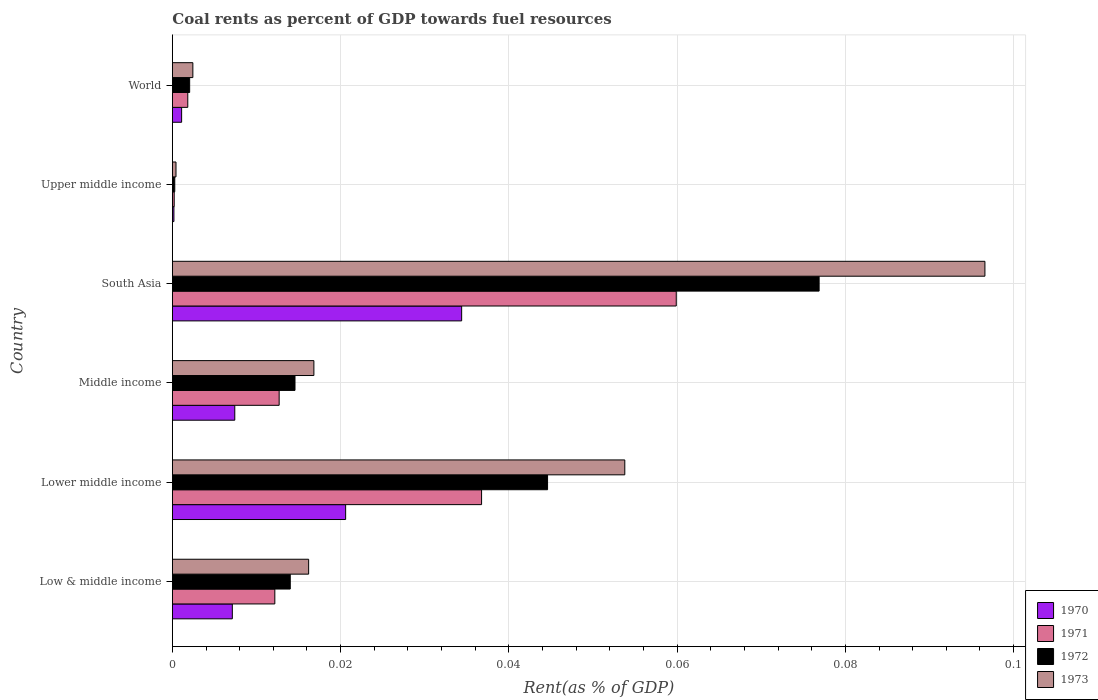What is the label of the 1st group of bars from the top?
Keep it short and to the point. World. What is the coal rent in 1973 in Lower middle income?
Ensure brevity in your answer.  0.05. Across all countries, what is the maximum coal rent in 1971?
Your response must be concise. 0.06. Across all countries, what is the minimum coal rent in 1972?
Provide a succinct answer. 0. In which country was the coal rent in 1972 minimum?
Make the answer very short. Upper middle income. What is the total coal rent in 1971 in the graph?
Provide a short and direct response. 0.12. What is the difference between the coal rent in 1971 in Lower middle income and that in World?
Provide a succinct answer. 0.03. What is the difference between the coal rent in 1973 in Lower middle income and the coal rent in 1970 in Upper middle income?
Offer a very short reply. 0.05. What is the average coal rent in 1970 per country?
Provide a succinct answer. 0.01. What is the difference between the coal rent in 1970 and coal rent in 1973 in South Asia?
Keep it short and to the point. -0.06. What is the ratio of the coal rent in 1971 in Middle income to that in South Asia?
Your answer should be compact. 0.21. Is the coal rent in 1971 in Low & middle income less than that in Middle income?
Offer a terse response. Yes. Is the difference between the coal rent in 1970 in Lower middle income and South Asia greater than the difference between the coal rent in 1973 in Lower middle income and South Asia?
Your answer should be very brief. Yes. What is the difference between the highest and the second highest coal rent in 1973?
Your answer should be very brief. 0.04. What is the difference between the highest and the lowest coal rent in 1972?
Provide a succinct answer. 0.08. Is the sum of the coal rent in 1970 in Lower middle income and Upper middle income greater than the maximum coal rent in 1973 across all countries?
Offer a very short reply. No. What does the 2nd bar from the top in Upper middle income represents?
Offer a very short reply. 1972. How many countries are there in the graph?
Give a very brief answer. 6. What is the difference between two consecutive major ticks on the X-axis?
Offer a very short reply. 0.02. Does the graph contain any zero values?
Offer a terse response. No. Does the graph contain grids?
Provide a succinct answer. Yes. How are the legend labels stacked?
Provide a succinct answer. Vertical. What is the title of the graph?
Provide a short and direct response. Coal rents as percent of GDP towards fuel resources. What is the label or title of the X-axis?
Your response must be concise. Rent(as % of GDP). What is the label or title of the Y-axis?
Ensure brevity in your answer.  Country. What is the Rent(as % of GDP) of 1970 in Low & middle income?
Offer a very short reply. 0.01. What is the Rent(as % of GDP) in 1971 in Low & middle income?
Give a very brief answer. 0.01. What is the Rent(as % of GDP) of 1972 in Low & middle income?
Your answer should be compact. 0.01. What is the Rent(as % of GDP) of 1973 in Low & middle income?
Your answer should be compact. 0.02. What is the Rent(as % of GDP) of 1970 in Lower middle income?
Offer a very short reply. 0.02. What is the Rent(as % of GDP) of 1971 in Lower middle income?
Keep it short and to the point. 0.04. What is the Rent(as % of GDP) of 1972 in Lower middle income?
Give a very brief answer. 0.04. What is the Rent(as % of GDP) of 1973 in Lower middle income?
Your answer should be very brief. 0.05. What is the Rent(as % of GDP) in 1970 in Middle income?
Your answer should be very brief. 0.01. What is the Rent(as % of GDP) in 1971 in Middle income?
Your response must be concise. 0.01. What is the Rent(as % of GDP) of 1972 in Middle income?
Offer a very short reply. 0.01. What is the Rent(as % of GDP) in 1973 in Middle income?
Offer a terse response. 0.02. What is the Rent(as % of GDP) in 1970 in South Asia?
Keep it short and to the point. 0.03. What is the Rent(as % of GDP) of 1971 in South Asia?
Make the answer very short. 0.06. What is the Rent(as % of GDP) of 1972 in South Asia?
Provide a short and direct response. 0.08. What is the Rent(as % of GDP) of 1973 in South Asia?
Keep it short and to the point. 0.1. What is the Rent(as % of GDP) of 1970 in Upper middle income?
Ensure brevity in your answer.  0. What is the Rent(as % of GDP) of 1971 in Upper middle income?
Give a very brief answer. 0. What is the Rent(as % of GDP) in 1972 in Upper middle income?
Your answer should be very brief. 0. What is the Rent(as % of GDP) of 1973 in Upper middle income?
Make the answer very short. 0. What is the Rent(as % of GDP) in 1970 in World?
Offer a very short reply. 0. What is the Rent(as % of GDP) in 1971 in World?
Your answer should be compact. 0. What is the Rent(as % of GDP) in 1972 in World?
Your response must be concise. 0. What is the Rent(as % of GDP) of 1973 in World?
Give a very brief answer. 0. Across all countries, what is the maximum Rent(as % of GDP) in 1970?
Ensure brevity in your answer.  0.03. Across all countries, what is the maximum Rent(as % of GDP) in 1971?
Ensure brevity in your answer.  0.06. Across all countries, what is the maximum Rent(as % of GDP) of 1972?
Your answer should be compact. 0.08. Across all countries, what is the maximum Rent(as % of GDP) in 1973?
Keep it short and to the point. 0.1. Across all countries, what is the minimum Rent(as % of GDP) in 1970?
Offer a terse response. 0. Across all countries, what is the minimum Rent(as % of GDP) in 1971?
Your answer should be very brief. 0. Across all countries, what is the minimum Rent(as % of GDP) in 1972?
Offer a terse response. 0. Across all countries, what is the minimum Rent(as % of GDP) in 1973?
Offer a terse response. 0. What is the total Rent(as % of GDP) in 1970 in the graph?
Provide a short and direct response. 0.07. What is the total Rent(as % of GDP) in 1971 in the graph?
Offer a very short reply. 0.12. What is the total Rent(as % of GDP) in 1972 in the graph?
Offer a very short reply. 0.15. What is the total Rent(as % of GDP) in 1973 in the graph?
Make the answer very short. 0.19. What is the difference between the Rent(as % of GDP) of 1970 in Low & middle income and that in Lower middle income?
Offer a very short reply. -0.01. What is the difference between the Rent(as % of GDP) of 1971 in Low & middle income and that in Lower middle income?
Ensure brevity in your answer.  -0.02. What is the difference between the Rent(as % of GDP) of 1972 in Low & middle income and that in Lower middle income?
Offer a terse response. -0.03. What is the difference between the Rent(as % of GDP) in 1973 in Low & middle income and that in Lower middle income?
Your answer should be compact. -0.04. What is the difference between the Rent(as % of GDP) of 1970 in Low & middle income and that in Middle income?
Provide a succinct answer. -0. What is the difference between the Rent(as % of GDP) in 1971 in Low & middle income and that in Middle income?
Provide a succinct answer. -0. What is the difference between the Rent(as % of GDP) in 1972 in Low & middle income and that in Middle income?
Offer a terse response. -0. What is the difference between the Rent(as % of GDP) in 1973 in Low & middle income and that in Middle income?
Make the answer very short. -0. What is the difference between the Rent(as % of GDP) of 1970 in Low & middle income and that in South Asia?
Your answer should be compact. -0.03. What is the difference between the Rent(as % of GDP) of 1971 in Low & middle income and that in South Asia?
Give a very brief answer. -0.05. What is the difference between the Rent(as % of GDP) of 1972 in Low & middle income and that in South Asia?
Provide a succinct answer. -0.06. What is the difference between the Rent(as % of GDP) in 1973 in Low & middle income and that in South Asia?
Offer a very short reply. -0.08. What is the difference between the Rent(as % of GDP) of 1970 in Low & middle income and that in Upper middle income?
Your answer should be compact. 0.01. What is the difference between the Rent(as % of GDP) in 1971 in Low & middle income and that in Upper middle income?
Make the answer very short. 0.01. What is the difference between the Rent(as % of GDP) in 1972 in Low & middle income and that in Upper middle income?
Your answer should be compact. 0.01. What is the difference between the Rent(as % of GDP) in 1973 in Low & middle income and that in Upper middle income?
Give a very brief answer. 0.02. What is the difference between the Rent(as % of GDP) in 1970 in Low & middle income and that in World?
Offer a very short reply. 0.01. What is the difference between the Rent(as % of GDP) of 1971 in Low & middle income and that in World?
Ensure brevity in your answer.  0.01. What is the difference between the Rent(as % of GDP) of 1972 in Low & middle income and that in World?
Your answer should be very brief. 0.01. What is the difference between the Rent(as % of GDP) of 1973 in Low & middle income and that in World?
Keep it short and to the point. 0.01. What is the difference between the Rent(as % of GDP) in 1970 in Lower middle income and that in Middle income?
Keep it short and to the point. 0.01. What is the difference between the Rent(as % of GDP) in 1971 in Lower middle income and that in Middle income?
Your answer should be very brief. 0.02. What is the difference between the Rent(as % of GDP) of 1973 in Lower middle income and that in Middle income?
Offer a very short reply. 0.04. What is the difference between the Rent(as % of GDP) in 1970 in Lower middle income and that in South Asia?
Ensure brevity in your answer.  -0.01. What is the difference between the Rent(as % of GDP) in 1971 in Lower middle income and that in South Asia?
Offer a very short reply. -0.02. What is the difference between the Rent(as % of GDP) of 1972 in Lower middle income and that in South Asia?
Offer a very short reply. -0.03. What is the difference between the Rent(as % of GDP) in 1973 in Lower middle income and that in South Asia?
Offer a very short reply. -0.04. What is the difference between the Rent(as % of GDP) of 1970 in Lower middle income and that in Upper middle income?
Keep it short and to the point. 0.02. What is the difference between the Rent(as % of GDP) of 1971 in Lower middle income and that in Upper middle income?
Ensure brevity in your answer.  0.04. What is the difference between the Rent(as % of GDP) of 1972 in Lower middle income and that in Upper middle income?
Your answer should be compact. 0.04. What is the difference between the Rent(as % of GDP) in 1973 in Lower middle income and that in Upper middle income?
Offer a terse response. 0.05. What is the difference between the Rent(as % of GDP) of 1970 in Lower middle income and that in World?
Your response must be concise. 0.02. What is the difference between the Rent(as % of GDP) of 1971 in Lower middle income and that in World?
Offer a terse response. 0.03. What is the difference between the Rent(as % of GDP) of 1972 in Lower middle income and that in World?
Offer a very short reply. 0.04. What is the difference between the Rent(as % of GDP) in 1973 in Lower middle income and that in World?
Ensure brevity in your answer.  0.05. What is the difference between the Rent(as % of GDP) of 1970 in Middle income and that in South Asia?
Your answer should be compact. -0.03. What is the difference between the Rent(as % of GDP) in 1971 in Middle income and that in South Asia?
Provide a succinct answer. -0.05. What is the difference between the Rent(as % of GDP) of 1972 in Middle income and that in South Asia?
Your response must be concise. -0.06. What is the difference between the Rent(as % of GDP) in 1973 in Middle income and that in South Asia?
Your response must be concise. -0.08. What is the difference between the Rent(as % of GDP) of 1970 in Middle income and that in Upper middle income?
Your answer should be very brief. 0.01. What is the difference between the Rent(as % of GDP) in 1971 in Middle income and that in Upper middle income?
Give a very brief answer. 0.01. What is the difference between the Rent(as % of GDP) in 1972 in Middle income and that in Upper middle income?
Offer a very short reply. 0.01. What is the difference between the Rent(as % of GDP) in 1973 in Middle income and that in Upper middle income?
Your response must be concise. 0.02. What is the difference between the Rent(as % of GDP) in 1970 in Middle income and that in World?
Offer a terse response. 0.01. What is the difference between the Rent(as % of GDP) of 1971 in Middle income and that in World?
Provide a succinct answer. 0.01. What is the difference between the Rent(as % of GDP) of 1972 in Middle income and that in World?
Ensure brevity in your answer.  0.01. What is the difference between the Rent(as % of GDP) in 1973 in Middle income and that in World?
Your answer should be very brief. 0.01. What is the difference between the Rent(as % of GDP) of 1970 in South Asia and that in Upper middle income?
Keep it short and to the point. 0.03. What is the difference between the Rent(as % of GDP) in 1971 in South Asia and that in Upper middle income?
Your response must be concise. 0.06. What is the difference between the Rent(as % of GDP) of 1972 in South Asia and that in Upper middle income?
Provide a succinct answer. 0.08. What is the difference between the Rent(as % of GDP) of 1973 in South Asia and that in Upper middle income?
Offer a very short reply. 0.1. What is the difference between the Rent(as % of GDP) in 1970 in South Asia and that in World?
Keep it short and to the point. 0.03. What is the difference between the Rent(as % of GDP) of 1971 in South Asia and that in World?
Your answer should be very brief. 0.06. What is the difference between the Rent(as % of GDP) of 1972 in South Asia and that in World?
Your answer should be very brief. 0.07. What is the difference between the Rent(as % of GDP) of 1973 in South Asia and that in World?
Provide a short and direct response. 0.09. What is the difference between the Rent(as % of GDP) in 1970 in Upper middle income and that in World?
Keep it short and to the point. -0. What is the difference between the Rent(as % of GDP) of 1971 in Upper middle income and that in World?
Your answer should be compact. -0. What is the difference between the Rent(as % of GDP) of 1972 in Upper middle income and that in World?
Provide a short and direct response. -0. What is the difference between the Rent(as % of GDP) in 1973 in Upper middle income and that in World?
Your answer should be very brief. -0. What is the difference between the Rent(as % of GDP) in 1970 in Low & middle income and the Rent(as % of GDP) in 1971 in Lower middle income?
Your answer should be very brief. -0.03. What is the difference between the Rent(as % of GDP) of 1970 in Low & middle income and the Rent(as % of GDP) of 1972 in Lower middle income?
Provide a short and direct response. -0.04. What is the difference between the Rent(as % of GDP) in 1970 in Low & middle income and the Rent(as % of GDP) in 1973 in Lower middle income?
Make the answer very short. -0.05. What is the difference between the Rent(as % of GDP) of 1971 in Low & middle income and the Rent(as % of GDP) of 1972 in Lower middle income?
Your answer should be very brief. -0.03. What is the difference between the Rent(as % of GDP) in 1971 in Low & middle income and the Rent(as % of GDP) in 1973 in Lower middle income?
Your answer should be very brief. -0.04. What is the difference between the Rent(as % of GDP) of 1972 in Low & middle income and the Rent(as % of GDP) of 1973 in Lower middle income?
Give a very brief answer. -0.04. What is the difference between the Rent(as % of GDP) of 1970 in Low & middle income and the Rent(as % of GDP) of 1971 in Middle income?
Provide a short and direct response. -0.01. What is the difference between the Rent(as % of GDP) of 1970 in Low & middle income and the Rent(as % of GDP) of 1972 in Middle income?
Your response must be concise. -0.01. What is the difference between the Rent(as % of GDP) of 1970 in Low & middle income and the Rent(as % of GDP) of 1973 in Middle income?
Give a very brief answer. -0.01. What is the difference between the Rent(as % of GDP) of 1971 in Low & middle income and the Rent(as % of GDP) of 1972 in Middle income?
Your answer should be very brief. -0. What is the difference between the Rent(as % of GDP) of 1971 in Low & middle income and the Rent(as % of GDP) of 1973 in Middle income?
Your response must be concise. -0. What is the difference between the Rent(as % of GDP) of 1972 in Low & middle income and the Rent(as % of GDP) of 1973 in Middle income?
Give a very brief answer. -0. What is the difference between the Rent(as % of GDP) in 1970 in Low & middle income and the Rent(as % of GDP) in 1971 in South Asia?
Give a very brief answer. -0.05. What is the difference between the Rent(as % of GDP) of 1970 in Low & middle income and the Rent(as % of GDP) of 1972 in South Asia?
Give a very brief answer. -0.07. What is the difference between the Rent(as % of GDP) in 1970 in Low & middle income and the Rent(as % of GDP) in 1973 in South Asia?
Your response must be concise. -0.09. What is the difference between the Rent(as % of GDP) of 1971 in Low & middle income and the Rent(as % of GDP) of 1972 in South Asia?
Your answer should be very brief. -0.06. What is the difference between the Rent(as % of GDP) in 1971 in Low & middle income and the Rent(as % of GDP) in 1973 in South Asia?
Your answer should be very brief. -0.08. What is the difference between the Rent(as % of GDP) of 1972 in Low & middle income and the Rent(as % of GDP) of 1973 in South Asia?
Make the answer very short. -0.08. What is the difference between the Rent(as % of GDP) of 1970 in Low & middle income and the Rent(as % of GDP) of 1971 in Upper middle income?
Offer a very short reply. 0.01. What is the difference between the Rent(as % of GDP) in 1970 in Low & middle income and the Rent(as % of GDP) in 1972 in Upper middle income?
Provide a short and direct response. 0.01. What is the difference between the Rent(as % of GDP) in 1970 in Low & middle income and the Rent(as % of GDP) in 1973 in Upper middle income?
Your answer should be compact. 0.01. What is the difference between the Rent(as % of GDP) in 1971 in Low & middle income and the Rent(as % of GDP) in 1972 in Upper middle income?
Make the answer very short. 0.01. What is the difference between the Rent(as % of GDP) in 1971 in Low & middle income and the Rent(as % of GDP) in 1973 in Upper middle income?
Provide a succinct answer. 0.01. What is the difference between the Rent(as % of GDP) in 1972 in Low & middle income and the Rent(as % of GDP) in 1973 in Upper middle income?
Your answer should be very brief. 0.01. What is the difference between the Rent(as % of GDP) in 1970 in Low & middle income and the Rent(as % of GDP) in 1971 in World?
Provide a succinct answer. 0.01. What is the difference between the Rent(as % of GDP) of 1970 in Low & middle income and the Rent(as % of GDP) of 1972 in World?
Offer a terse response. 0.01. What is the difference between the Rent(as % of GDP) in 1970 in Low & middle income and the Rent(as % of GDP) in 1973 in World?
Your answer should be compact. 0. What is the difference between the Rent(as % of GDP) of 1971 in Low & middle income and the Rent(as % of GDP) of 1972 in World?
Provide a succinct answer. 0.01. What is the difference between the Rent(as % of GDP) in 1971 in Low & middle income and the Rent(as % of GDP) in 1973 in World?
Your response must be concise. 0.01. What is the difference between the Rent(as % of GDP) of 1972 in Low & middle income and the Rent(as % of GDP) of 1973 in World?
Your answer should be compact. 0.01. What is the difference between the Rent(as % of GDP) in 1970 in Lower middle income and the Rent(as % of GDP) in 1971 in Middle income?
Offer a terse response. 0.01. What is the difference between the Rent(as % of GDP) in 1970 in Lower middle income and the Rent(as % of GDP) in 1972 in Middle income?
Provide a succinct answer. 0.01. What is the difference between the Rent(as % of GDP) in 1970 in Lower middle income and the Rent(as % of GDP) in 1973 in Middle income?
Give a very brief answer. 0. What is the difference between the Rent(as % of GDP) in 1971 in Lower middle income and the Rent(as % of GDP) in 1972 in Middle income?
Make the answer very short. 0.02. What is the difference between the Rent(as % of GDP) of 1971 in Lower middle income and the Rent(as % of GDP) of 1973 in Middle income?
Give a very brief answer. 0.02. What is the difference between the Rent(as % of GDP) of 1972 in Lower middle income and the Rent(as % of GDP) of 1973 in Middle income?
Provide a short and direct response. 0.03. What is the difference between the Rent(as % of GDP) of 1970 in Lower middle income and the Rent(as % of GDP) of 1971 in South Asia?
Your answer should be very brief. -0.04. What is the difference between the Rent(as % of GDP) of 1970 in Lower middle income and the Rent(as % of GDP) of 1972 in South Asia?
Ensure brevity in your answer.  -0.06. What is the difference between the Rent(as % of GDP) of 1970 in Lower middle income and the Rent(as % of GDP) of 1973 in South Asia?
Make the answer very short. -0.08. What is the difference between the Rent(as % of GDP) of 1971 in Lower middle income and the Rent(as % of GDP) of 1972 in South Asia?
Keep it short and to the point. -0.04. What is the difference between the Rent(as % of GDP) of 1971 in Lower middle income and the Rent(as % of GDP) of 1973 in South Asia?
Make the answer very short. -0.06. What is the difference between the Rent(as % of GDP) in 1972 in Lower middle income and the Rent(as % of GDP) in 1973 in South Asia?
Ensure brevity in your answer.  -0.05. What is the difference between the Rent(as % of GDP) in 1970 in Lower middle income and the Rent(as % of GDP) in 1971 in Upper middle income?
Offer a very short reply. 0.02. What is the difference between the Rent(as % of GDP) in 1970 in Lower middle income and the Rent(as % of GDP) in 1972 in Upper middle income?
Make the answer very short. 0.02. What is the difference between the Rent(as % of GDP) in 1970 in Lower middle income and the Rent(as % of GDP) in 1973 in Upper middle income?
Your answer should be compact. 0.02. What is the difference between the Rent(as % of GDP) in 1971 in Lower middle income and the Rent(as % of GDP) in 1972 in Upper middle income?
Your answer should be very brief. 0.04. What is the difference between the Rent(as % of GDP) of 1971 in Lower middle income and the Rent(as % of GDP) of 1973 in Upper middle income?
Keep it short and to the point. 0.04. What is the difference between the Rent(as % of GDP) in 1972 in Lower middle income and the Rent(as % of GDP) in 1973 in Upper middle income?
Make the answer very short. 0.04. What is the difference between the Rent(as % of GDP) of 1970 in Lower middle income and the Rent(as % of GDP) of 1971 in World?
Ensure brevity in your answer.  0.02. What is the difference between the Rent(as % of GDP) in 1970 in Lower middle income and the Rent(as % of GDP) in 1972 in World?
Give a very brief answer. 0.02. What is the difference between the Rent(as % of GDP) in 1970 in Lower middle income and the Rent(as % of GDP) in 1973 in World?
Make the answer very short. 0.02. What is the difference between the Rent(as % of GDP) of 1971 in Lower middle income and the Rent(as % of GDP) of 1972 in World?
Your response must be concise. 0.03. What is the difference between the Rent(as % of GDP) of 1971 in Lower middle income and the Rent(as % of GDP) of 1973 in World?
Your answer should be compact. 0.03. What is the difference between the Rent(as % of GDP) of 1972 in Lower middle income and the Rent(as % of GDP) of 1973 in World?
Your answer should be compact. 0.04. What is the difference between the Rent(as % of GDP) of 1970 in Middle income and the Rent(as % of GDP) of 1971 in South Asia?
Provide a short and direct response. -0.05. What is the difference between the Rent(as % of GDP) of 1970 in Middle income and the Rent(as % of GDP) of 1972 in South Asia?
Your answer should be very brief. -0.07. What is the difference between the Rent(as % of GDP) of 1970 in Middle income and the Rent(as % of GDP) of 1973 in South Asia?
Your answer should be compact. -0.09. What is the difference between the Rent(as % of GDP) in 1971 in Middle income and the Rent(as % of GDP) in 1972 in South Asia?
Ensure brevity in your answer.  -0.06. What is the difference between the Rent(as % of GDP) of 1971 in Middle income and the Rent(as % of GDP) of 1973 in South Asia?
Provide a short and direct response. -0.08. What is the difference between the Rent(as % of GDP) of 1972 in Middle income and the Rent(as % of GDP) of 1973 in South Asia?
Give a very brief answer. -0.08. What is the difference between the Rent(as % of GDP) in 1970 in Middle income and the Rent(as % of GDP) in 1971 in Upper middle income?
Your answer should be compact. 0.01. What is the difference between the Rent(as % of GDP) of 1970 in Middle income and the Rent(as % of GDP) of 1972 in Upper middle income?
Your answer should be compact. 0.01. What is the difference between the Rent(as % of GDP) of 1970 in Middle income and the Rent(as % of GDP) of 1973 in Upper middle income?
Your answer should be compact. 0.01. What is the difference between the Rent(as % of GDP) in 1971 in Middle income and the Rent(as % of GDP) in 1972 in Upper middle income?
Ensure brevity in your answer.  0.01. What is the difference between the Rent(as % of GDP) in 1971 in Middle income and the Rent(as % of GDP) in 1973 in Upper middle income?
Your answer should be compact. 0.01. What is the difference between the Rent(as % of GDP) in 1972 in Middle income and the Rent(as % of GDP) in 1973 in Upper middle income?
Offer a terse response. 0.01. What is the difference between the Rent(as % of GDP) in 1970 in Middle income and the Rent(as % of GDP) in 1971 in World?
Ensure brevity in your answer.  0.01. What is the difference between the Rent(as % of GDP) of 1970 in Middle income and the Rent(as % of GDP) of 1972 in World?
Offer a terse response. 0.01. What is the difference between the Rent(as % of GDP) in 1970 in Middle income and the Rent(as % of GDP) in 1973 in World?
Provide a succinct answer. 0.01. What is the difference between the Rent(as % of GDP) of 1971 in Middle income and the Rent(as % of GDP) of 1972 in World?
Provide a succinct answer. 0.01. What is the difference between the Rent(as % of GDP) of 1971 in Middle income and the Rent(as % of GDP) of 1973 in World?
Ensure brevity in your answer.  0.01. What is the difference between the Rent(as % of GDP) in 1972 in Middle income and the Rent(as % of GDP) in 1973 in World?
Provide a succinct answer. 0.01. What is the difference between the Rent(as % of GDP) in 1970 in South Asia and the Rent(as % of GDP) in 1971 in Upper middle income?
Offer a terse response. 0.03. What is the difference between the Rent(as % of GDP) in 1970 in South Asia and the Rent(as % of GDP) in 1972 in Upper middle income?
Ensure brevity in your answer.  0.03. What is the difference between the Rent(as % of GDP) of 1970 in South Asia and the Rent(as % of GDP) of 1973 in Upper middle income?
Keep it short and to the point. 0.03. What is the difference between the Rent(as % of GDP) of 1971 in South Asia and the Rent(as % of GDP) of 1972 in Upper middle income?
Give a very brief answer. 0.06. What is the difference between the Rent(as % of GDP) in 1971 in South Asia and the Rent(as % of GDP) in 1973 in Upper middle income?
Offer a terse response. 0.06. What is the difference between the Rent(as % of GDP) of 1972 in South Asia and the Rent(as % of GDP) of 1973 in Upper middle income?
Give a very brief answer. 0.08. What is the difference between the Rent(as % of GDP) in 1970 in South Asia and the Rent(as % of GDP) in 1971 in World?
Offer a very short reply. 0.03. What is the difference between the Rent(as % of GDP) of 1970 in South Asia and the Rent(as % of GDP) of 1972 in World?
Give a very brief answer. 0.03. What is the difference between the Rent(as % of GDP) in 1970 in South Asia and the Rent(as % of GDP) in 1973 in World?
Your answer should be very brief. 0.03. What is the difference between the Rent(as % of GDP) of 1971 in South Asia and the Rent(as % of GDP) of 1972 in World?
Offer a very short reply. 0.06. What is the difference between the Rent(as % of GDP) in 1971 in South Asia and the Rent(as % of GDP) in 1973 in World?
Ensure brevity in your answer.  0.06. What is the difference between the Rent(as % of GDP) of 1972 in South Asia and the Rent(as % of GDP) of 1973 in World?
Your answer should be very brief. 0.07. What is the difference between the Rent(as % of GDP) in 1970 in Upper middle income and the Rent(as % of GDP) in 1971 in World?
Provide a succinct answer. -0. What is the difference between the Rent(as % of GDP) in 1970 in Upper middle income and the Rent(as % of GDP) in 1972 in World?
Your answer should be very brief. -0. What is the difference between the Rent(as % of GDP) of 1970 in Upper middle income and the Rent(as % of GDP) of 1973 in World?
Ensure brevity in your answer.  -0. What is the difference between the Rent(as % of GDP) in 1971 in Upper middle income and the Rent(as % of GDP) in 1972 in World?
Offer a terse response. -0. What is the difference between the Rent(as % of GDP) of 1971 in Upper middle income and the Rent(as % of GDP) of 1973 in World?
Ensure brevity in your answer.  -0. What is the difference between the Rent(as % of GDP) of 1972 in Upper middle income and the Rent(as % of GDP) of 1973 in World?
Provide a succinct answer. -0. What is the average Rent(as % of GDP) in 1970 per country?
Your response must be concise. 0.01. What is the average Rent(as % of GDP) in 1971 per country?
Keep it short and to the point. 0.02. What is the average Rent(as % of GDP) in 1972 per country?
Offer a terse response. 0.03. What is the average Rent(as % of GDP) of 1973 per country?
Offer a terse response. 0.03. What is the difference between the Rent(as % of GDP) of 1970 and Rent(as % of GDP) of 1971 in Low & middle income?
Provide a short and direct response. -0.01. What is the difference between the Rent(as % of GDP) of 1970 and Rent(as % of GDP) of 1972 in Low & middle income?
Your answer should be compact. -0.01. What is the difference between the Rent(as % of GDP) of 1970 and Rent(as % of GDP) of 1973 in Low & middle income?
Ensure brevity in your answer.  -0.01. What is the difference between the Rent(as % of GDP) of 1971 and Rent(as % of GDP) of 1972 in Low & middle income?
Keep it short and to the point. -0. What is the difference between the Rent(as % of GDP) of 1971 and Rent(as % of GDP) of 1973 in Low & middle income?
Provide a succinct answer. -0. What is the difference between the Rent(as % of GDP) in 1972 and Rent(as % of GDP) in 1973 in Low & middle income?
Your response must be concise. -0. What is the difference between the Rent(as % of GDP) in 1970 and Rent(as % of GDP) in 1971 in Lower middle income?
Your response must be concise. -0.02. What is the difference between the Rent(as % of GDP) of 1970 and Rent(as % of GDP) of 1972 in Lower middle income?
Your answer should be very brief. -0.02. What is the difference between the Rent(as % of GDP) of 1970 and Rent(as % of GDP) of 1973 in Lower middle income?
Give a very brief answer. -0.03. What is the difference between the Rent(as % of GDP) in 1971 and Rent(as % of GDP) in 1972 in Lower middle income?
Provide a short and direct response. -0.01. What is the difference between the Rent(as % of GDP) of 1971 and Rent(as % of GDP) of 1973 in Lower middle income?
Keep it short and to the point. -0.02. What is the difference between the Rent(as % of GDP) of 1972 and Rent(as % of GDP) of 1973 in Lower middle income?
Provide a succinct answer. -0.01. What is the difference between the Rent(as % of GDP) in 1970 and Rent(as % of GDP) in 1971 in Middle income?
Offer a very short reply. -0.01. What is the difference between the Rent(as % of GDP) in 1970 and Rent(as % of GDP) in 1972 in Middle income?
Provide a succinct answer. -0.01. What is the difference between the Rent(as % of GDP) in 1970 and Rent(as % of GDP) in 1973 in Middle income?
Provide a short and direct response. -0.01. What is the difference between the Rent(as % of GDP) in 1971 and Rent(as % of GDP) in 1972 in Middle income?
Keep it short and to the point. -0. What is the difference between the Rent(as % of GDP) in 1971 and Rent(as % of GDP) in 1973 in Middle income?
Offer a terse response. -0. What is the difference between the Rent(as % of GDP) of 1972 and Rent(as % of GDP) of 1973 in Middle income?
Keep it short and to the point. -0. What is the difference between the Rent(as % of GDP) in 1970 and Rent(as % of GDP) in 1971 in South Asia?
Provide a short and direct response. -0.03. What is the difference between the Rent(as % of GDP) of 1970 and Rent(as % of GDP) of 1972 in South Asia?
Ensure brevity in your answer.  -0.04. What is the difference between the Rent(as % of GDP) of 1970 and Rent(as % of GDP) of 1973 in South Asia?
Provide a succinct answer. -0.06. What is the difference between the Rent(as % of GDP) of 1971 and Rent(as % of GDP) of 1972 in South Asia?
Offer a very short reply. -0.02. What is the difference between the Rent(as % of GDP) in 1971 and Rent(as % of GDP) in 1973 in South Asia?
Offer a very short reply. -0.04. What is the difference between the Rent(as % of GDP) of 1972 and Rent(as % of GDP) of 1973 in South Asia?
Provide a succinct answer. -0.02. What is the difference between the Rent(as % of GDP) in 1970 and Rent(as % of GDP) in 1971 in Upper middle income?
Keep it short and to the point. -0. What is the difference between the Rent(as % of GDP) of 1970 and Rent(as % of GDP) of 1972 in Upper middle income?
Ensure brevity in your answer.  -0. What is the difference between the Rent(as % of GDP) in 1970 and Rent(as % of GDP) in 1973 in Upper middle income?
Your answer should be very brief. -0. What is the difference between the Rent(as % of GDP) in 1971 and Rent(as % of GDP) in 1972 in Upper middle income?
Give a very brief answer. -0. What is the difference between the Rent(as % of GDP) of 1971 and Rent(as % of GDP) of 1973 in Upper middle income?
Your answer should be very brief. -0. What is the difference between the Rent(as % of GDP) in 1972 and Rent(as % of GDP) in 1973 in Upper middle income?
Your response must be concise. -0. What is the difference between the Rent(as % of GDP) in 1970 and Rent(as % of GDP) in 1971 in World?
Give a very brief answer. -0. What is the difference between the Rent(as % of GDP) of 1970 and Rent(as % of GDP) of 1972 in World?
Your response must be concise. -0. What is the difference between the Rent(as % of GDP) in 1970 and Rent(as % of GDP) in 1973 in World?
Give a very brief answer. -0. What is the difference between the Rent(as % of GDP) of 1971 and Rent(as % of GDP) of 1972 in World?
Ensure brevity in your answer.  -0. What is the difference between the Rent(as % of GDP) of 1971 and Rent(as % of GDP) of 1973 in World?
Your answer should be compact. -0. What is the difference between the Rent(as % of GDP) of 1972 and Rent(as % of GDP) of 1973 in World?
Keep it short and to the point. -0. What is the ratio of the Rent(as % of GDP) in 1970 in Low & middle income to that in Lower middle income?
Ensure brevity in your answer.  0.35. What is the ratio of the Rent(as % of GDP) in 1971 in Low & middle income to that in Lower middle income?
Your answer should be very brief. 0.33. What is the ratio of the Rent(as % of GDP) of 1972 in Low & middle income to that in Lower middle income?
Ensure brevity in your answer.  0.31. What is the ratio of the Rent(as % of GDP) in 1973 in Low & middle income to that in Lower middle income?
Give a very brief answer. 0.3. What is the ratio of the Rent(as % of GDP) of 1970 in Low & middle income to that in Middle income?
Your answer should be compact. 0.96. What is the ratio of the Rent(as % of GDP) in 1971 in Low & middle income to that in Middle income?
Provide a succinct answer. 0.96. What is the ratio of the Rent(as % of GDP) in 1972 in Low & middle income to that in Middle income?
Your response must be concise. 0.96. What is the ratio of the Rent(as % of GDP) in 1973 in Low & middle income to that in Middle income?
Your response must be concise. 0.96. What is the ratio of the Rent(as % of GDP) in 1970 in Low & middle income to that in South Asia?
Offer a terse response. 0.21. What is the ratio of the Rent(as % of GDP) in 1971 in Low & middle income to that in South Asia?
Ensure brevity in your answer.  0.2. What is the ratio of the Rent(as % of GDP) of 1972 in Low & middle income to that in South Asia?
Give a very brief answer. 0.18. What is the ratio of the Rent(as % of GDP) of 1973 in Low & middle income to that in South Asia?
Provide a succinct answer. 0.17. What is the ratio of the Rent(as % of GDP) of 1970 in Low & middle income to that in Upper middle income?
Offer a terse response. 38.77. What is the ratio of the Rent(as % of GDP) in 1971 in Low & middle income to that in Upper middle income?
Provide a short and direct response. 55.66. What is the ratio of the Rent(as % of GDP) in 1972 in Low & middle income to that in Upper middle income?
Your answer should be very brief. 49.28. What is the ratio of the Rent(as % of GDP) of 1973 in Low & middle income to that in Upper middle income?
Your answer should be very brief. 37.59. What is the ratio of the Rent(as % of GDP) of 1970 in Low & middle income to that in World?
Your answer should be very brief. 6.48. What is the ratio of the Rent(as % of GDP) of 1971 in Low & middle income to that in World?
Ensure brevity in your answer.  6.65. What is the ratio of the Rent(as % of GDP) in 1972 in Low & middle income to that in World?
Offer a terse response. 6.82. What is the ratio of the Rent(as % of GDP) in 1973 in Low & middle income to that in World?
Make the answer very short. 6.65. What is the ratio of the Rent(as % of GDP) in 1970 in Lower middle income to that in Middle income?
Offer a very short reply. 2.78. What is the ratio of the Rent(as % of GDP) of 1971 in Lower middle income to that in Middle income?
Give a very brief answer. 2.9. What is the ratio of the Rent(as % of GDP) of 1972 in Lower middle income to that in Middle income?
Offer a very short reply. 3.06. What is the ratio of the Rent(as % of GDP) of 1973 in Lower middle income to that in Middle income?
Your answer should be compact. 3.2. What is the ratio of the Rent(as % of GDP) in 1970 in Lower middle income to that in South Asia?
Your answer should be compact. 0.6. What is the ratio of the Rent(as % of GDP) of 1971 in Lower middle income to that in South Asia?
Make the answer very short. 0.61. What is the ratio of the Rent(as % of GDP) of 1972 in Lower middle income to that in South Asia?
Keep it short and to the point. 0.58. What is the ratio of the Rent(as % of GDP) in 1973 in Lower middle income to that in South Asia?
Offer a very short reply. 0.56. What is the ratio of the Rent(as % of GDP) of 1970 in Lower middle income to that in Upper middle income?
Make the answer very short. 112.03. What is the ratio of the Rent(as % of GDP) of 1971 in Lower middle income to that in Upper middle income?
Ensure brevity in your answer.  167.98. What is the ratio of the Rent(as % of GDP) in 1972 in Lower middle income to that in Upper middle income?
Keep it short and to the point. 156.82. What is the ratio of the Rent(as % of GDP) in 1973 in Lower middle income to that in Upper middle income?
Provide a short and direct response. 124.82. What is the ratio of the Rent(as % of GDP) of 1970 in Lower middle income to that in World?
Your response must be concise. 18.71. What is the ratio of the Rent(as % of GDP) in 1971 in Lower middle income to that in World?
Provide a short and direct response. 20.06. What is the ratio of the Rent(as % of GDP) of 1972 in Lower middle income to that in World?
Give a very brief answer. 21.7. What is the ratio of the Rent(as % of GDP) of 1973 in Lower middle income to that in World?
Your answer should be very brief. 22.07. What is the ratio of the Rent(as % of GDP) of 1970 in Middle income to that in South Asia?
Offer a terse response. 0.22. What is the ratio of the Rent(as % of GDP) of 1971 in Middle income to that in South Asia?
Your answer should be very brief. 0.21. What is the ratio of the Rent(as % of GDP) of 1972 in Middle income to that in South Asia?
Offer a terse response. 0.19. What is the ratio of the Rent(as % of GDP) in 1973 in Middle income to that in South Asia?
Offer a terse response. 0.17. What is the ratio of the Rent(as % of GDP) of 1970 in Middle income to that in Upper middle income?
Your answer should be very brief. 40.36. What is the ratio of the Rent(as % of GDP) in 1971 in Middle income to that in Upper middle income?
Offer a terse response. 58.01. What is the ratio of the Rent(as % of GDP) in 1972 in Middle income to that in Upper middle income?
Provide a short and direct response. 51.25. What is the ratio of the Rent(as % of GDP) of 1973 in Middle income to that in Upper middle income?
Give a very brief answer. 39.04. What is the ratio of the Rent(as % of GDP) of 1970 in Middle income to that in World?
Make the answer very short. 6.74. What is the ratio of the Rent(as % of GDP) in 1971 in Middle income to that in World?
Your response must be concise. 6.93. What is the ratio of the Rent(as % of GDP) of 1972 in Middle income to that in World?
Give a very brief answer. 7.09. What is the ratio of the Rent(as % of GDP) of 1973 in Middle income to that in World?
Your response must be concise. 6.91. What is the ratio of the Rent(as % of GDP) in 1970 in South Asia to that in Upper middle income?
Keep it short and to the point. 187.05. What is the ratio of the Rent(as % of GDP) of 1971 in South Asia to that in Upper middle income?
Ensure brevity in your answer.  273.74. What is the ratio of the Rent(as % of GDP) in 1972 in South Asia to that in Upper middle income?
Your answer should be very brief. 270.32. What is the ratio of the Rent(as % of GDP) of 1973 in South Asia to that in Upper middle income?
Offer a very short reply. 224.18. What is the ratio of the Rent(as % of GDP) of 1970 in South Asia to that in World?
Provide a succinct answer. 31.24. What is the ratio of the Rent(as % of GDP) in 1971 in South Asia to that in World?
Your answer should be very brief. 32.69. What is the ratio of the Rent(as % of GDP) in 1972 in South Asia to that in World?
Give a very brief answer. 37.41. What is the ratio of the Rent(as % of GDP) of 1973 in South Asia to that in World?
Provide a short and direct response. 39.65. What is the ratio of the Rent(as % of GDP) of 1970 in Upper middle income to that in World?
Keep it short and to the point. 0.17. What is the ratio of the Rent(as % of GDP) of 1971 in Upper middle income to that in World?
Your answer should be compact. 0.12. What is the ratio of the Rent(as % of GDP) of 1972 in Upper middle income to that in World?
Provide a succinct answer. 0.14. What is the ratio of the Rent(as % of GDP) of 1973 in Upper middle income to that in World?
Your answer should be very brief. 0.18. What is the difference between the highest and the second highest Rent(as % of GDP) of 1970?
Provide a short and direct response. 0.01. What is the difference between the highest and the second highest Rent(as % of GDP) of 1971?
Your answer should be compact. 0.02. What is the difference between the highest and the second highest Rent(as % of GDP) in 1972?
Make the answer very short. 0.03. What is the difference between the highest and the second highest Rent(as % of GDP) of 1973?
Make the answer very short. 0.04. What is the difference between the highest and the lowest Rent(as % of GDP) in 1970?
Offer a terse response. 0.03. What is the difference between the highest and the lowest Rent(as % of GDP) in 1971?
Provide a succinct answer. 0.06. What is the difference between the highest and the lowest Rent(as % of GDP) of 1972?
Your answer should be compact. 0.08. What is the difference between the highest and the lowest Rent(as % of GDP) in 1973?
Give a very brief answer. 0.1. 